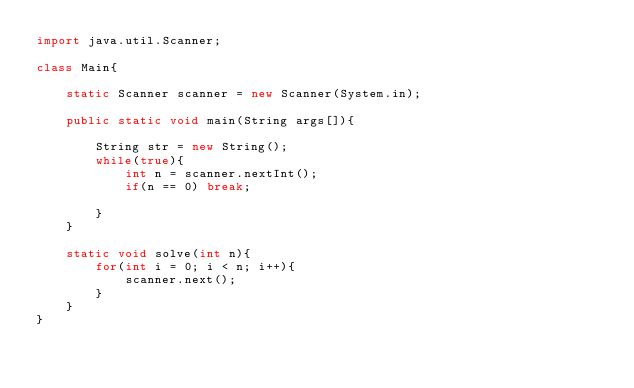Convert code to text. <code><loc_0><loc_0><loc_500><loc_500><_Java_>import java.util.Scanner;

class Main{

	static Scanner scanner = new Scanner(System.in);
	
	public static void main(String args[]){

		String str = new String();
		while(true){
			int n = scanner.nextInt();
			if(n == 0) break;

		}
	}

	static void solve(int n){
		for(int i = 0; i < n; i++){
			scanner.next();
		}
	}
}</code> 